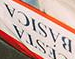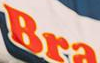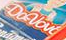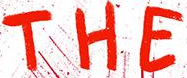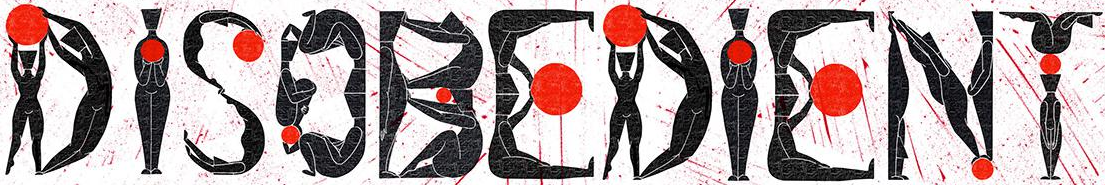What words are shown in these images in order, separated by a semicolon? BÁSICA; Bra; Davbv; THE; DISOBEDIENT 